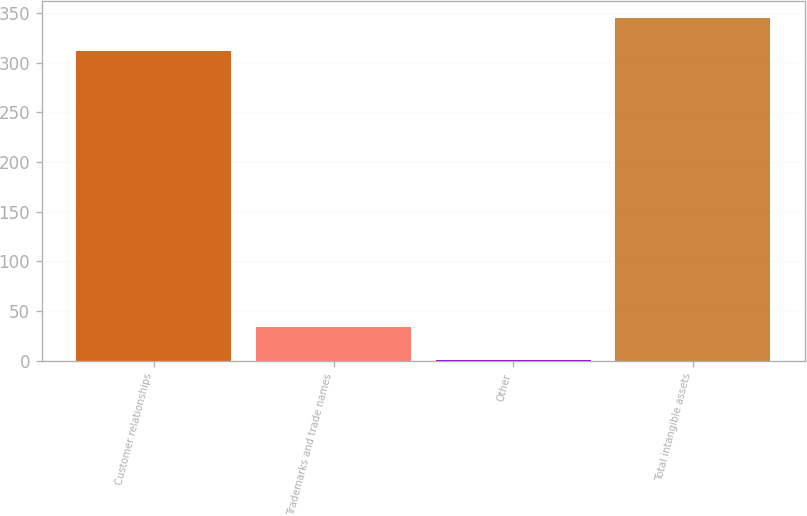Convert chart to OTSL. <chart><loc_0><loc_0><loc_500><loc_500><bar_chart><fcel>Customer relationships<fcel>Trademarks and trade names<fcel>Other<fcel>Total intangible assets<nl><fcel>311.5<fcel>33.53<fcel>0.2<fcel>344.83<nl></chart> 